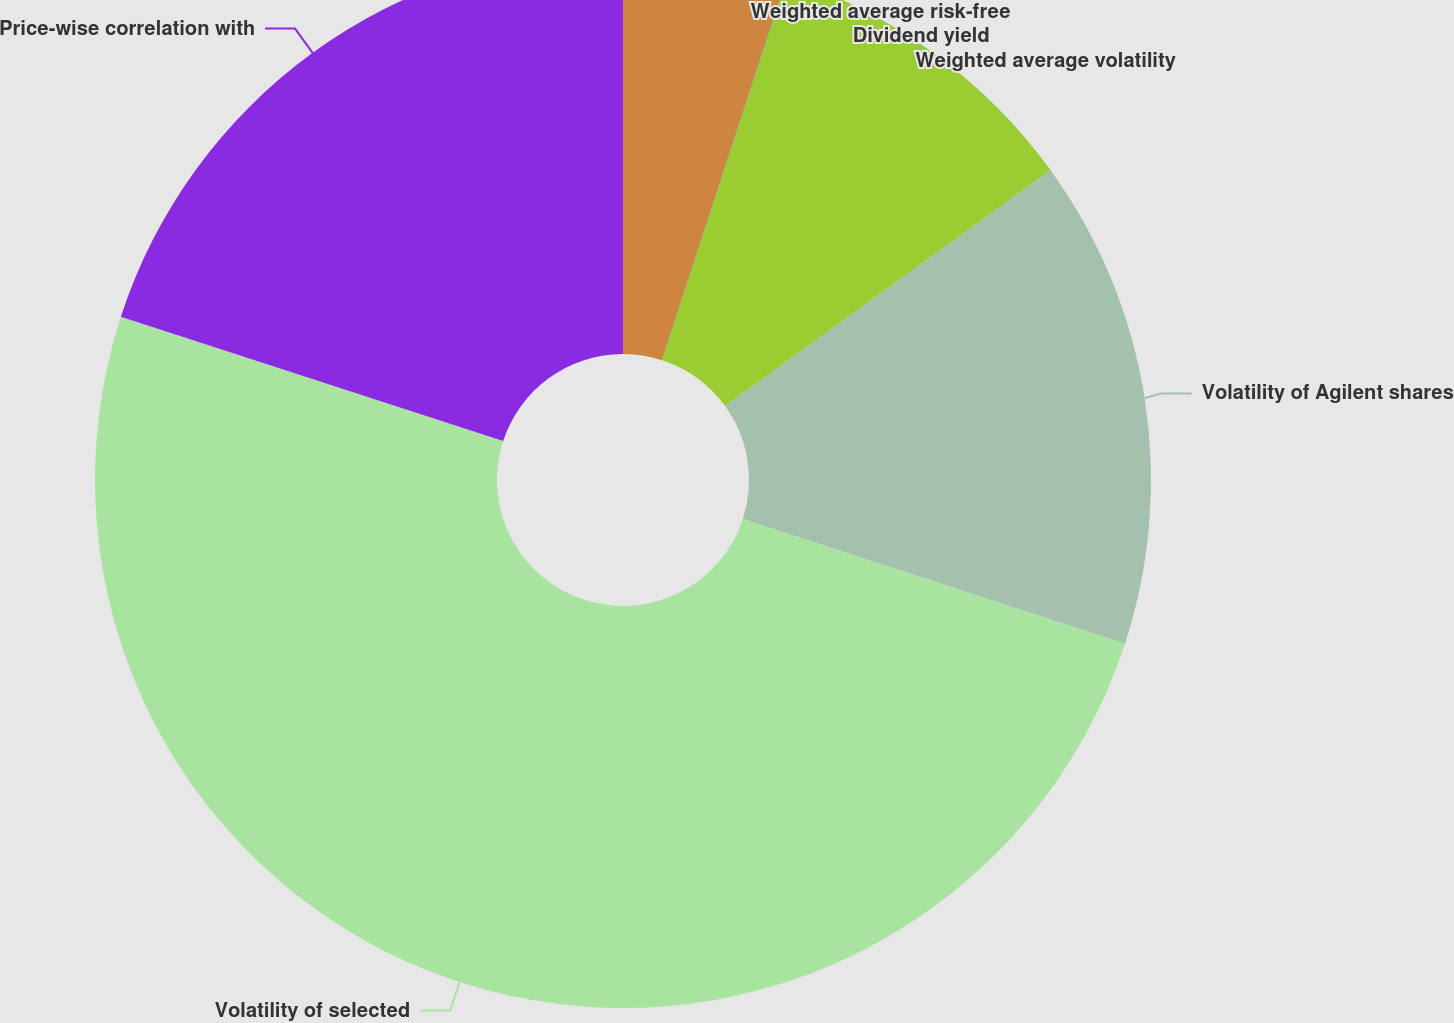Convert chart to OTSL. <chart><loc_0><loc_0><loc_500><loc_500><pie_chart><fcel>Weighted average risk-free<fcel>Dividend yield<fcel>Weighted average volatility<fcel>Volatility of Agilent shares<fcel>Volatility of selected<fcel>Price-wise correlation with<nl><fcel>5.01%<fcel>0.01%<fcel>10.0%<fcel>15.0%<fcel>49.98%<fcel>20.0%<nl></chart> 